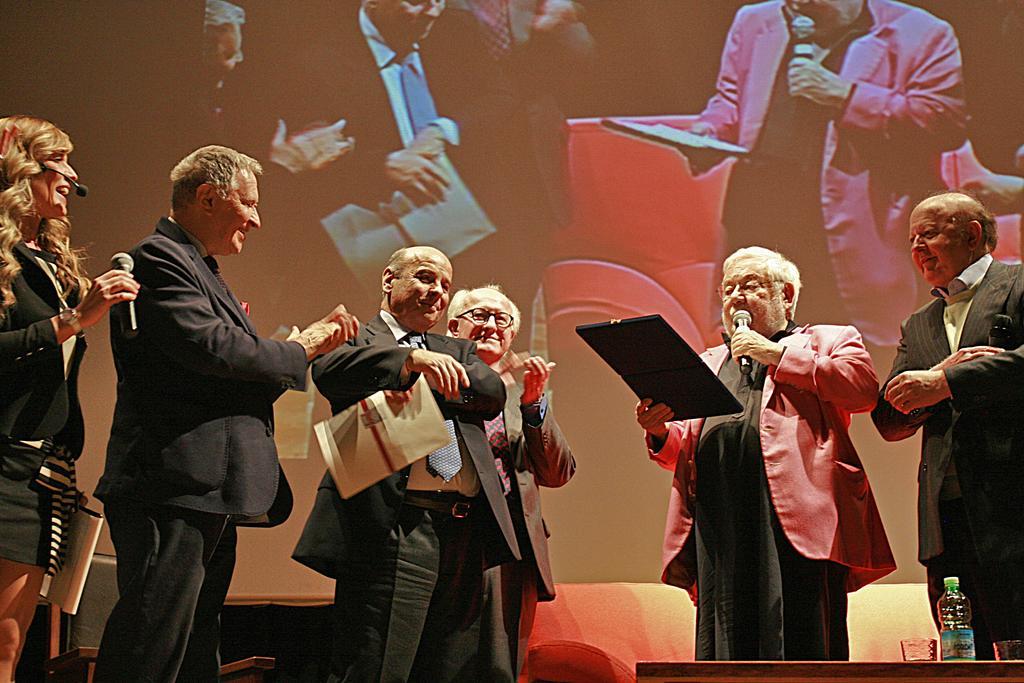How would you summarize this image in a sentence or two? In this image we can see some group of persons standing on stage some are holding microphones and some papers in their hands and in the background of the image there is a screen. 